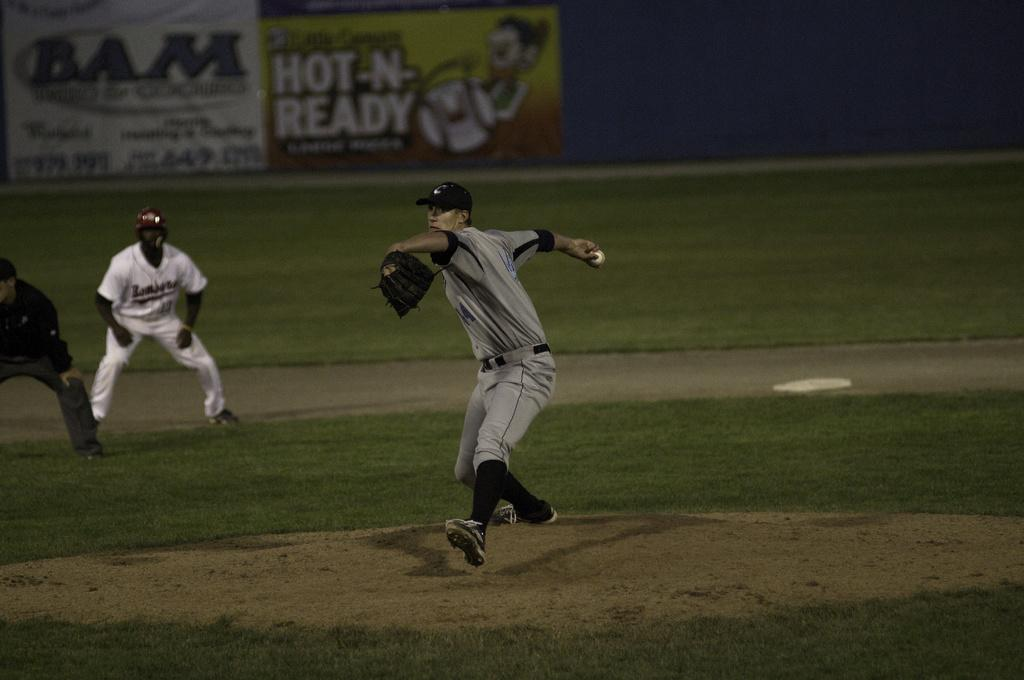What is the main action being performed by the person in the image? There is a person throwing a ball in the image. How many other people are present in the image? There are two other people standing on the grass in the image. What type of surface are the people standing on? The grass is visible in the image. What can be seen in the background of the image? There is a banner in the background of the image. What type of quince is being discussed by the people in the image? There is no mention of a quince or any discussion in the image; it features a person throwing a ball and two other people standing on the grass. 